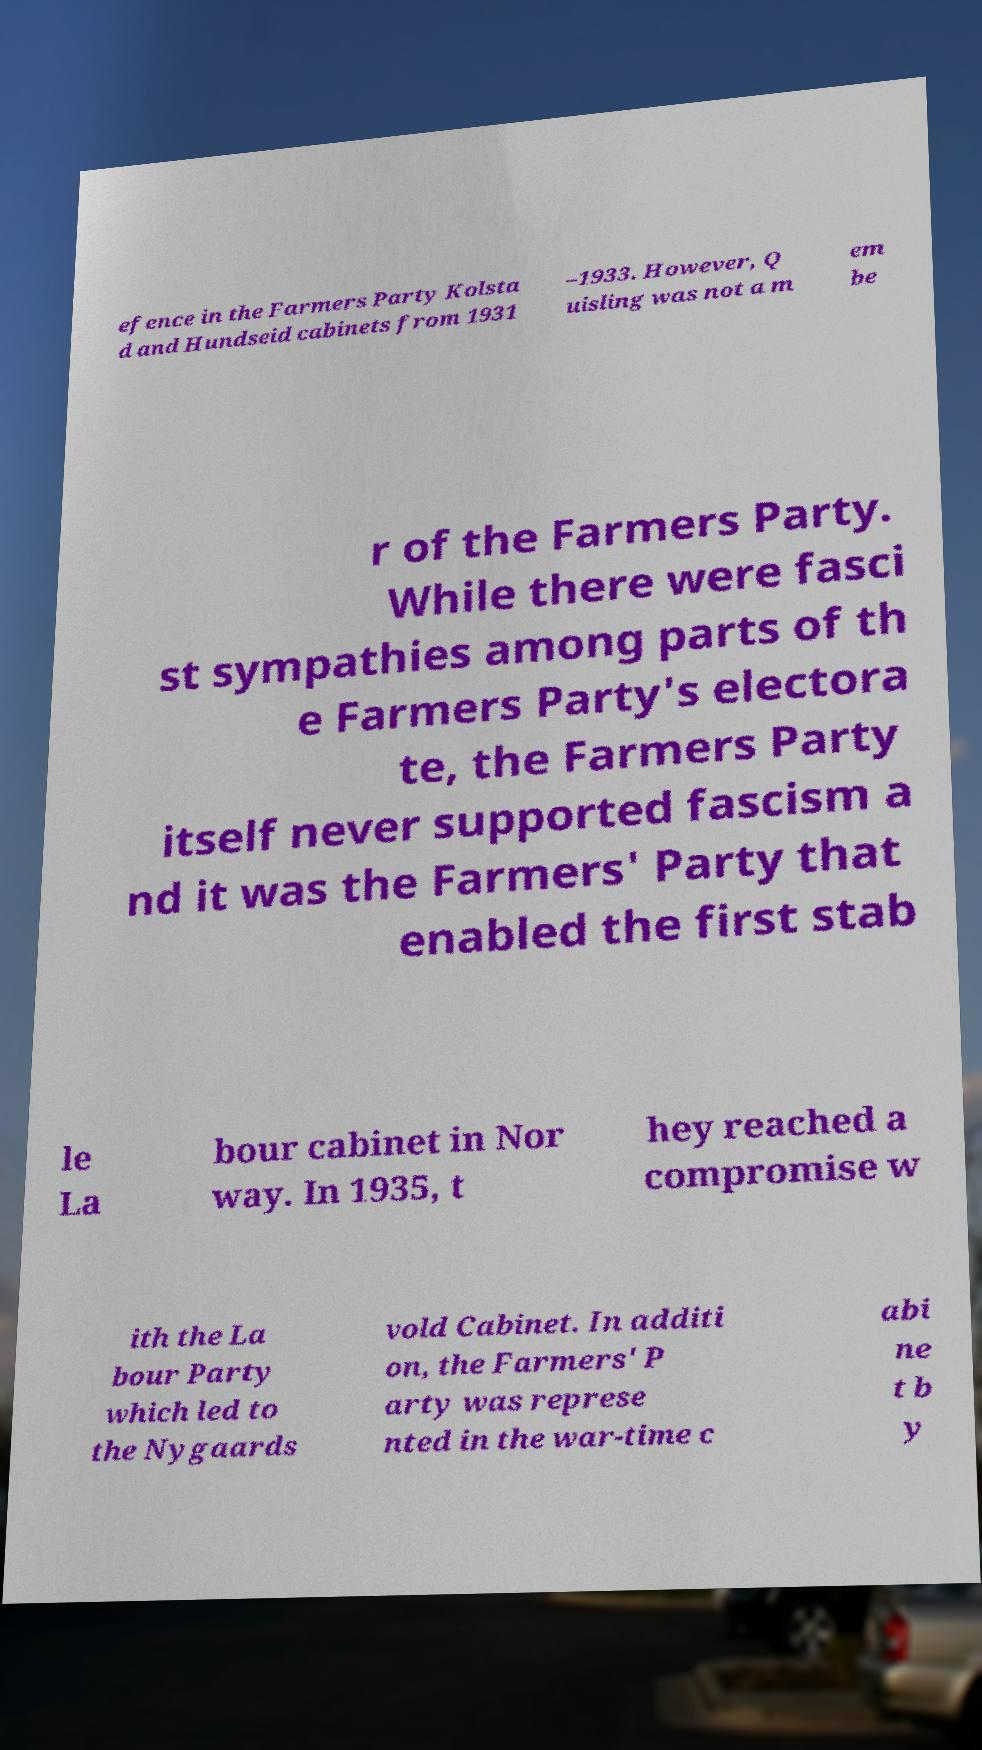Could you extract and type out the text from this image? efence in the Farmers Party Kolsta d and Hundseid cabinets from 1931 –1933. However, Q uisling was not a m em be r of the Farmers Party. While there were fasci st sympathies among parts of th e Farmers Party's electora te, the Farmers Party itself never supported fascism a nd it was the Farmers' Party that enabled the first stab le La bour cabinet in Nor way. In 1935, t hey reached a compromise w ith the La bour Party which led to the Nygaards vold Cabinet. In additi on, the Farmers' P arty was represe nted in the war-time c abi ne t b y 